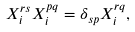Convert formula to latex. <formula><loc_0><loc_0><loc_500><loc_500>X _ { i } ^ { r s } X _ { i } ^ { p q } = \delta _ { s p } X _ { i } ^ { r q } ,</formula> 